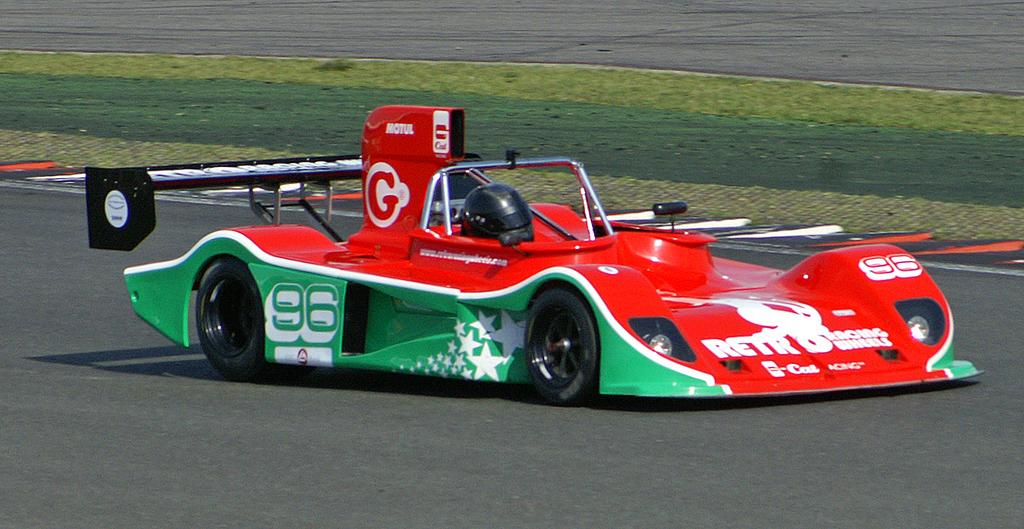What type of vehicle is on the road in the image? There is a race car on the road in the image. What safety gear is visible in the image? A helmet is visible in the image. What type of vegetation can be seen in the background of the image? There is grass in the background of the image. What language is the race car driver speaking in the image? There is no indication of the driver speaking in the image, nor is there any information about the language they might be speaking. 